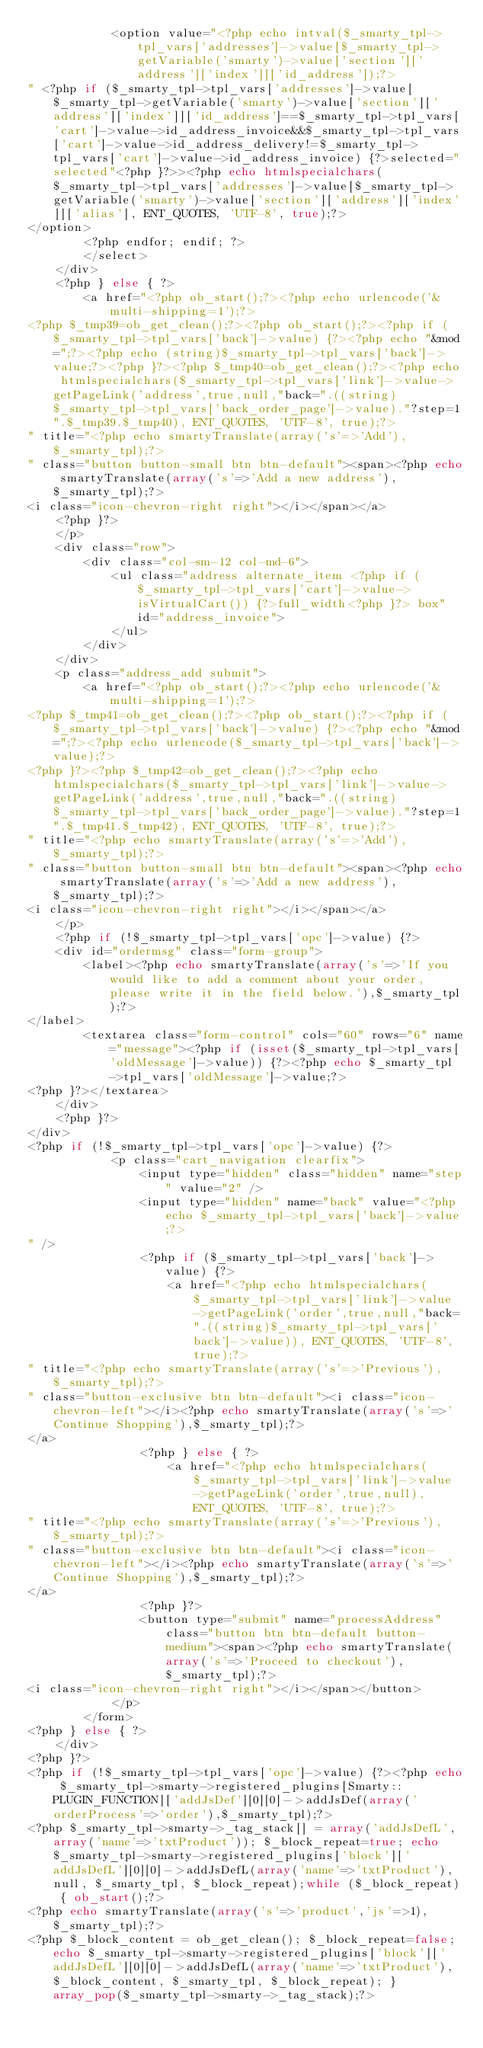<code> <loc_0><loc_0><loc_500><loc_500><_PHP_>			<option value="<?php echo intval($_smarty_tpl->tpl_vars['addresses']->value[$_smarty_tpl->getVariable('smarty')->value['section']['address']['index']]['id_address']);?>
" <?php if ($_smarty_tpl->tpl_vars['addresses']->value[$_smarty_tpl->getVariable('smarty')->value['section']['address']['index']]['id_address']==$_smarty_tpl->tpl_vars['cart']->value->id_address_invoice&&$_smarty_tpl->tpl_vars['cart']->value->id_address_delivery!=$_smarty_tpl->tpl_vars['cart']->value->id_address_invoice) {?>selected="selected"<?php }?>><?php echo htmlspecialchars($_smarty_tpl->tpl_vars['addresses']->value[$_smarty_tpl->getVariable('smarty')->value['section']['address']['index']]['alias'], ENT_QUOTES, 'UTF-8', true);?>
</option>
		<?php endfor; endif; ?>
		</select>
    </div>
	<?php } else { ?>
		<a href="<?php ob_start();?><?php echo urlencode('&multi-shipping=1');?>
<?php $_tmp39=ob_get_clean();?><?php ob_start();?><?php if ($_smarty_tpl->tpl_vars['back']->value) {?><?php echo "&mod=";?><?php echo (string)$_smarty_tpl->tpl_vars['back']->value;?><?php }?><?php $_tmp40=ob_get_clean();?><?php echo htmlspecialchars($_smarty_tpl->tpl_vars['link']->value->getPageLink('address',true,null,"back=".((string)$_smarty_tpl->tpl_vars['back_order_page']->value)."?step=1".$_tmp39.$_tmp40), ENT_QUOTES, 'UTF-8', true);?>
" title="<?php echo smartyTranslate(array('s'=>'Add'),$_smarty_tpl);?>
" class="button button-small btn btn-default"><span><?php echo smartyTranslate(array('s'=>'Add a new address'),$_smarty_tpl);?>
<i class="icon-chevron-right right"></i></span></a>
	<?php }?>
	</p>
	<div class="row">
    	<div class="col-sm-12 col-md-6">
            <ul class="address alternate_item <?php if ($_smarty_tpl->tpl_vars['cart']->value->isVirtualCart()) {?>full_width<?php }?> box" id="address_invoice">
            </ul>
        </div>
	</div>
	<p class="address_add submit">
		<a href="<?php ob_start();?><?php echo urlencode('&multi-shipping=1');?>
<?php $_tmp41=ob_get_clean();?><?php ob_start();?><?php if ($_smarty_tpl->tpl_vars['back']->value) {?><?php echo "&mod=";?><?php echo urlencode($_smarty_tpl->tpl_vars['back']->value);?>
<?php }?><?php $_tmp42=ob_get_clean();?><?php echo htmlspecialchars($_smarty_tpl->tpl_vars['link']->value->getPageLink('address',true,null,"back=".((string)$_smarty_tpl->tpl_vars['back_order_page']->value)."?step=1".$_tmp41.$_tmp42), ENT_QUOTES, 'UTF-8', true);?>
" title="<?php echo smartyTranslate(array('s'=>'Add'),$_smarty_tpl);?>
" class="button button-small btn btn-default"><span><?php echo smartyTranslate(array('s'=>'Add a new address'),$_smarty_tpl);?>
<i class="icon-chevron-right right"></i></span></a>
	</p>
	<?php if (!$_smarty_tpl->tpl_vars['opc']->value) {?>
	<div id="ordermsg" class="form-group">
		<label><?php echo smartyTranslate(array('s'=>'If you would like to add a comment about your order, please write it in the field below.'),$_smarty_tpl);?>
</label>
		<textarea class="form-control" cols="60" rows="6" name="message"><?php if (isset($_smarty_tpl->tpl_vars['oldMessage']->value)) {?><?php echo $_smarty_tpl->tpl_vars['oldMessage']->value;?>
<?php }?></textarea>
	</div>
	<?php }?>
</div>
<?php if (!$_smarty_tpl->tpl_vars['opc']->value) {?>
			<p class="cart_navigation clearfix">
				<input type="hidden" class="hidden" name="step" value="2" />
				<input type="hidden" name="back" value="<?php echo $_smarty_tpl->tpl_vars['back']->value;?>
" />
				<?php if ($_smarty_tpl->tpl_vars['back']->value) {?>
					<a href="<?php echo htmlspecialchars($_smarty_tpl->tpl_vars['link']->value->getPageLink('order',true,null,"back=".((string)$_smarty_tpl->tpl_vars['back']->value)), ENT_QUOTES, 'UTF-8', true);?>
" title="<?php echo smartyTranslate(array('s'=>'Previous'),$_smarty_tpl);?>
" class="button-exclusive btn btn-default"><i class="icon-chevron-left"></i><?php echo smartyTranslate(array('s'=>'Continue Shopping'),$_smarty_tpl);?>
</a>
				<?php } else { ?>
					<a href="<?php echo htmlspecialchars($_smarty_tpl->tpl_vars['link']->value->getPageLink('order',true,null), ENT_QUOTES, 'UTF-8', true);?>
" title="<?php echo smartyTranslate(array('s'=>'Previous'),$_smarty_tpl);?>
" class="button-exclusive btn btn-default"><i class="icon-chevron-left"></i><?php echo smartyTranslate(array('s'=>'Continue Shopping'),$_smarty_tpl);?>
</a>
				<?php }?>
		        <button type="submit" name="processAddress" class="button btn btn-default button-medium"><span><?php echo smartyTranslate(array('s'=>'Proceed to checkout'),$_smarty_tpl);?>
<i class="icon-chevron-right right"></i></span></button>
			</p>
		</form>
<?php } else { ?>
	</div>
<?php }?>
<?php if (!$_smarty_tpl->tpl_vars['opc']->value) {?><?php echo $_smarty_tpl->smarty->registered_plugins[Smarty::PLUGIN_FUNCTION]['addJsDef'][0][0]->addJsDef(array('orderProcess'=>'order'),$_smarty_tpl);?>
<?php $_smarty_tpl->smarty->_tag_stack[] = array('addJsDefL', array('name'=>'txtProduct')); $_block_repeat=true; echo $_smarty_tpl->smarty->registered_plugins['block']['addJsDefL'][0][0]->addJsDefL(array('name'=>'txtProduct'), null, $_smarty_tpl, $_block_repeat);while ($_block_repeat) { ob_start();?>
<?php echo smartyTranslate(array('s'=>'product','js'=>1),$_smarty_tpl);?>
<?php $_block_content = ob_get_clean(); $_block_repeat=false; echo $_smarty_tpl->smarty->registered_plugins['block']['addJsDefL'][0][0]->addJsDefL(array('name'=>'txtProduct'), $_block_content, $_smarty_tpl, $_block_repeat); } array_pop($_smarty_tpl->smarty->_tag_stack);?></code> 